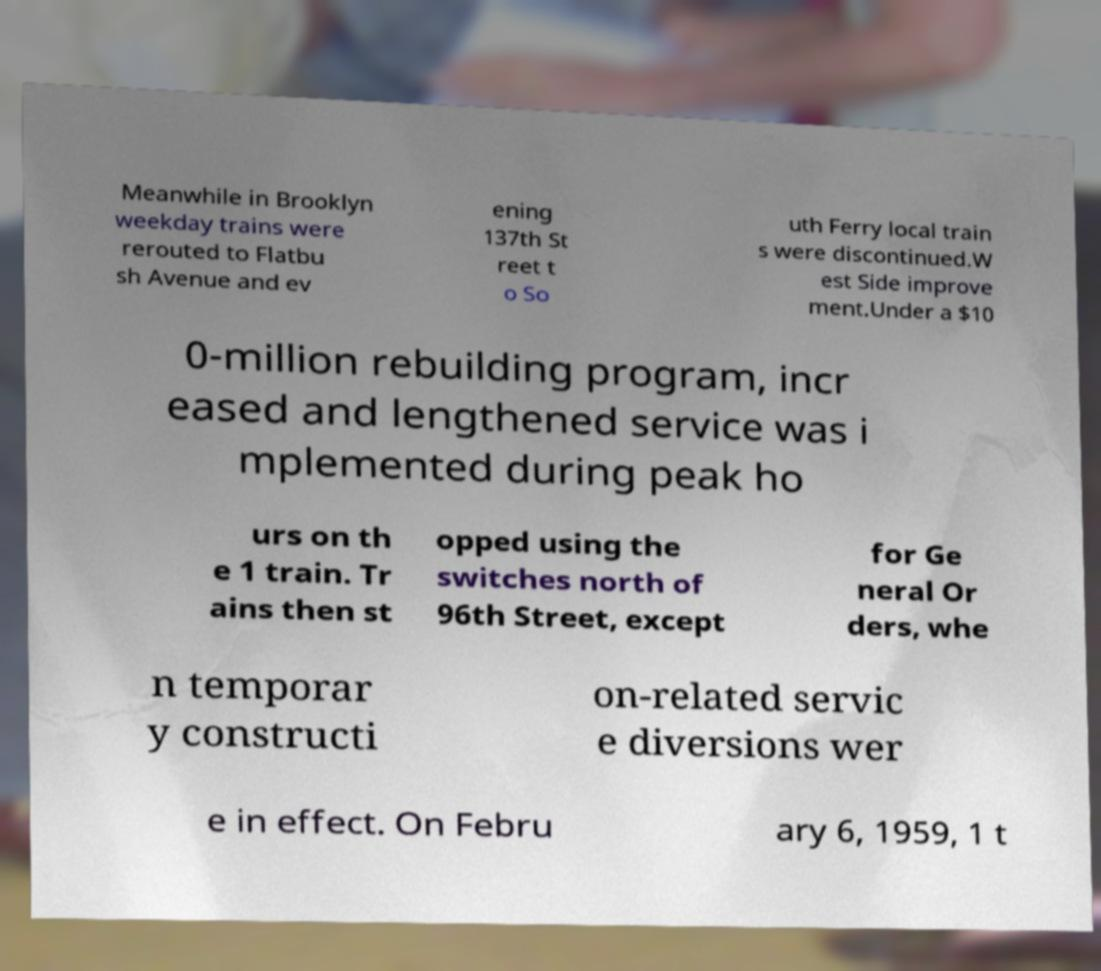Please read and relay the text visible in this image. What does it say? Meanwhile in Brooklyn weekday trains were rerouted to Flatbu sh Avenue and ev ening 137th St reet t o So uth Ferry local train s were discontinued.W est Side improve ment.Under a $10 0-million rebuilding program, incr eased and lengthened service was i mplemented during peak ho urs on th e 1 train. Tr ains then st opped using the switches north of 96th Street, except for Ge neral Or ders, whe n temporar y constructi on-related servic e diversions wer e in effect. On Febru ary 6, 1959, 1 t 